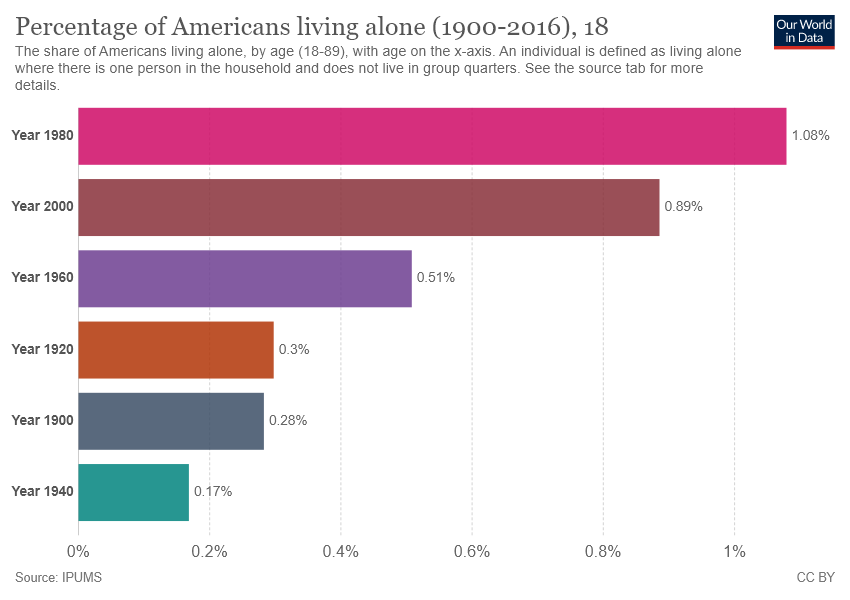Indicate a few pertinent items in this graphic. In 1940, only 0.17% of Americans lived alone. The median value of all the bars is 0.405. 